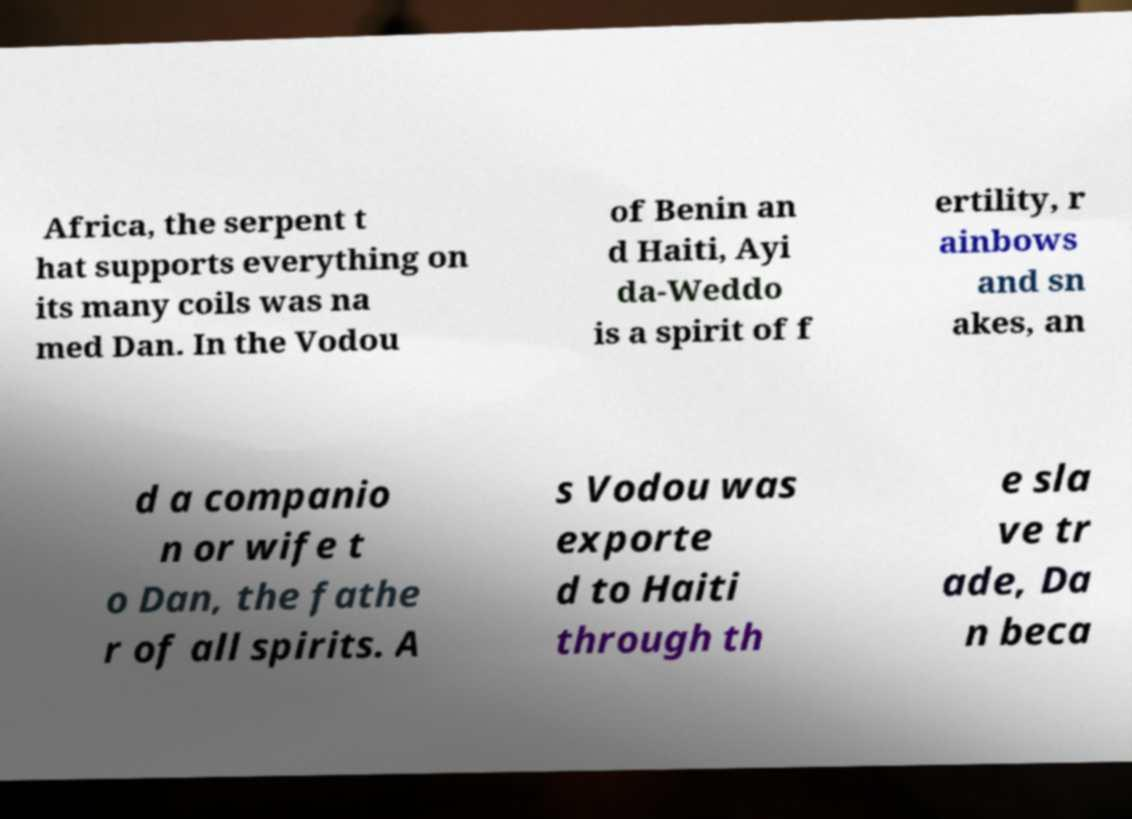Could you extract and type out the text from this image? Africa, the serpent t hat supports everything on its many coils was na med Dan. In the Vodou of Benin an d Haiti, Ayi da-Weddo is a spirit of f ertility, r ainbows and sn akes, an d a companio n or wife t o Dan, the fathe r of all spirits. A s Vodou was exporte d to Haiti through th e sla ve tr ade, Da n beca 